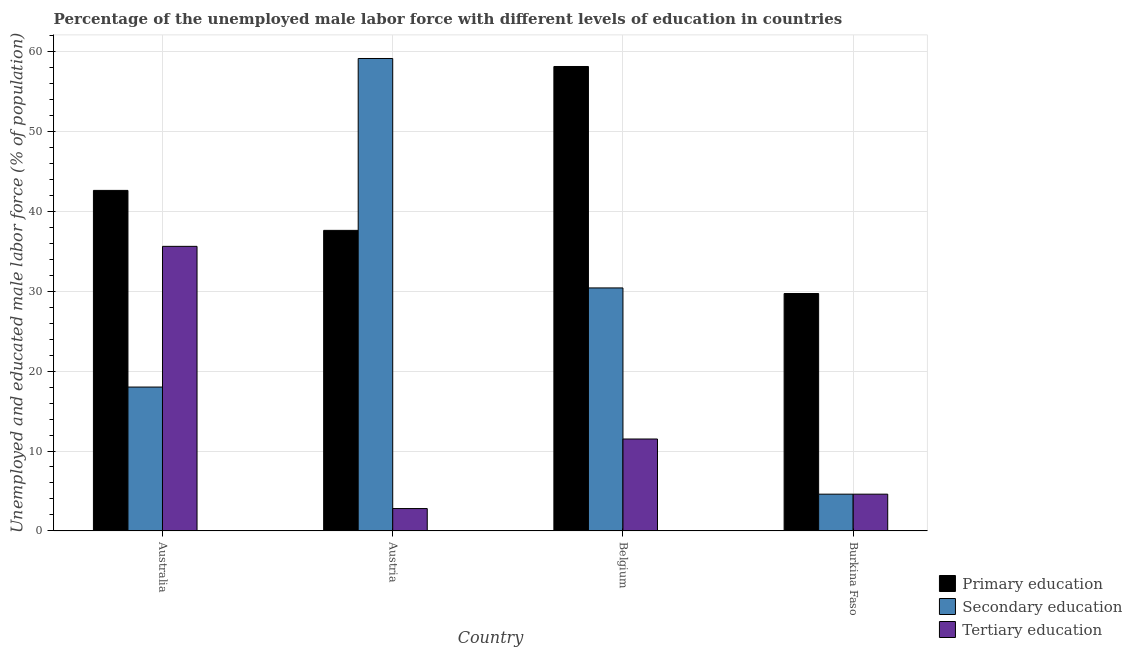In how many cases, is the number of bars for a given country not equal to the number of legend labels?
Keep it short and to the point. 0. What is the percentage of male labor force who received primary education in Belgium?
Make the answer very short. 58.1. Across all countries, what is the maximum percentage of male labor force who received tertiary education?
Keep it short and to the point. 35.6. Across all countries, what is the minimum percentage of male labor force who received tertiary education?
Give a very brief answer. 2.8. In which country was the percentage of male labor force who received secondary education minimum?
Keep it short and to the point. Burkina Faso. What is the total percentage of male labor force who received primary education in the graph?
Your response must be concise. 168. What is the difference between the percentage of male labor force who received tertiary education in Australia and that in Austria?
Make the answer very short. 32.8. What is the difference between the percentage of male labor force who received tertiary education in Australia and the percentage of male labor force who received secondary education in Austria?
Provide a short and direct response. -23.5. What is the average percentage of male labor force who received secondary education per country?
Your answer should be compact. 28.02. What is the difference between the percentage of male labor force who received tertiary education and percentage of male labor force who received primary education in Burkina Faso?
Give a very brief answer. -25.1. In how many countries, is the percentage of male labor force who received secondary education greater than 52 %?
Provide a short and direct response. 1. What is the ratio of the percentage of male labor force who received primary education in Australia to that in Austria?
Provide a short and direct response. 1.13. Is the percentage of male labor force who received tertiary education in Austria less than that in Belgium?
Keep it short and to the point. Yes. Is the difference between the percentage of male labor force who received primary education in Australia and Austria greater than the difference between the percentage of male labor force who received secondary education in Australia and Austria?
Ensure brevity in your answer.  Yes. What is the difference between the highest and the second highest percentage of male labor force who received secondary education?
Provide a succinct answer. 28.7. What is the difference between the highest and the lowest percentage of male labor force who received primary education?
Your answer should be very brief. 28.4. What does the 3rd bar from the left in Burkina Faso represents?
Keep it short and to the point. Tertiary education. What does the 2nd bar from the right in Burkina Faso represents?
Offer a very short reply. Secondary education. Is it the case that in every country, the sum of the percentage of male labor force who received primary education and percentage of male labor force who received secondary education is greater than the percentage of male labor force who received tertiary education?
Your response must be concise. Yes. Are all the bars in the graph horizontal?
Your answer should be very brief. No. How are the legend labels stacked?
Make the answer very short. Vertical. What is the title of the graph?
Make the answer very short. Percentage of the unemployed male labor force with different levels of education in countries. Does "Ages 50+" appear as one of the legend labels in the graph?
Make the answer very short. No. What is the label or title of the X-axis?
Your response must be concise. Country. What is the label or title of the Y-axis?
Make the answer very short. Unemployed and educated male labor force (% of population). What is the Unemployed and educated male labor force (% of population) in Primary education in Australia?
Ensure brevity in your answer.  42.6. What is the Unemployed and educated male labor force (% of population) of Tertiary education in Australia?
Give a very brief answer. 35.6. What is the Unemployed and educated male labor force (% of population) in Primary education in Austria?
Your answer should be compact. 37.6. What is the Unemployed and educated male labor force (% of population) in Secondary education in Austria?
Offer a terse response. 59.1. What is the Unemployed and educated male labor force (% of population) in Tertiary education in Austria?
Ensure brevity in your answer.  2.8. What is the Unemployed and educated male labor force (% of population) in Primary education in Belgium?
Provide a short and direct response. 58.1. What is the Unemployed and educated male labor force (% of population) of Secondary education in Belgium?
Make the answer very short. 30.4. What is the Unemployed and educated male labor force (% of population) in Primary education in Burkina Faso?
Give a very brief answer. 29.7. What is the Unemployed and educated male labor force (% of population) in Secondary education in Burkina Faso?
Your response must be concise. 4.6. What is the Unemployed and educated male labor force (% of population) in Tertiary education in Burkina Faso?
Ensure brevity in your answer.  4.6. Across all countries, what is the maximum Unemployed and educated male labor force (% of population) in Primary education?
Offer a terse response. 58.1. Across all countries, what is the maximum Unemployed and educated male labor force (% of population) in Secondary education?
Your answer should be very brief. 59.1. Across all countries, what is the maximum Unemployed and educated male labor force (% of population) of Tertiary education?
Provide a short and direct response. 35.6. Across all countries, what is the minimum Unemployed and educated male labor force (% of population) of Primary education?
Make the answer very short. 29.7. Across all countries, what is the minimum Unemployed and educated male labor force (% of population) in Secondary education?
Keep it short and to the point. 4.6. Across all countries, what is the minimum Unemployed and educated male labor force (% of population) of Tertiary education?
Keep it short and to the point. 2.8. What is the total Unemployed and educated male labor force (% of population) of Primary education in the graph?
Offer a very short reply. 168. What is the total Unemployed and educated male labor force (% of population) in Secondary education in the graph?
Offer a terse response. 112.1. What is the total Unemployed and educated male labor force (% of population) in Tertiary education in the graph?
Give a very brief answer. 54.5. What is the difference between the Unemployed and educated male labor force (% of population) in Secondary education in Australia and that in Austria?
Your answer should be compact. -41.1. What is the difference between the Unemployed and educated male labor force (% of population) of Tertiary education in Australia and that in Austria?
Your answer should be compact. 32.8. What is the difference between the Unemployed and educated male labor force (% of population) of Primary education in Australia and that in Belgium?
Make the answer very short. -15.5. What is the difference between the Unemployed and educated male labor force (% of population) in Secondary education in Australia and that in Belgium?
Offer a terse response. -12.4. What is the difference between the Unemployed and educated male labor force (% of population) in Tertiary education in Australia and that in Belgium?
Give a very brief answer. 24.1. What is the difference between the Unemployed and educated male labor force (% of population) of Secondary education in Australia and that in Burkina Faso?
Your response must be concise. 13.4. What is the difference between the Unemployed and educated male labor force (% of population) in Tertiary education in Australia and that in Burkina Faso?
Your answer should be very brief. 31. What is the difference between the Unemployed and educated male labor force (% of population) of Primary education in Austria and that in Belgium?
Your answer should be very brief. -20.5. What is the difference between the Unemployed and educated male labor force (% of population) of Secondary education in Austria and that in Belgium?
Your answer should be very brief. 28.7. What is the difference between the Unemployed and educated male labor force (% of population) in Tertiary education in Austria and that in Belgium?
Make the answer very short. -8.7. What is the difference between the Unemployed and educated male labor force (% of population) in Secondary education in Austria and that in Burkina Faso?
Keep it short and to the point. 54.5. What is the difference between the Unemployed and educated male labor force (% of population) of Primary education in Belgium and that in Burkina Faso?
Ensure brevity in your answer.  28.4. What is the difference between the Unemployed and educated male labor force (% of population) of Secondary education in Belgium and that in Burkina Faso?
Ensure brevity in your answer.  25.8. What is the difference between the Unemployed and educated male labor force (% of population) of Tertiary education in Belgium and that in Burkina Faso?
Provide a succinct answer. 6.9. What is the difference between the Unemployed and educated male labor force (% of population) of Primary education in Australia and the Unemployed and educated male labor force (% of population) of Secondary education in Austria?
Ensure brevity in your answer.  -16.5. What is the difference between the Unemployed and educated male labor force (% of population) in Primary education in Australia and the Unemployed and educated male labor force (% of population) in Tertiary education in Austria?
Offer a terse response. 39.8. What is the difference between the Unemployed and educated male labor force (% of population) of Secondary education in Australia and the Unemployed and educated male labor force (% of population) of Tertiary education in Austria?
Offer a terse response. 15.2. What is the difference between the Unemployed and educated male labor force (% of population) in Primary education in Australia and the Unemployed and educated male labor force (% of population) in Tertiary education in Belgium?
Your response must be concise. 31.1. What is the difference between the Unemployed and educated male labor force (% of population) of Secondary education in Australia and the Unemployed and educated male labor force (% of population) of Tertiary education in Belgium?
Offer a terse response. 6.5. What is the difference between the Unemployed and educated male labor force (% of population) in Primary education in Australia and the Unemployed and educated male labor force (% of population) in Secondary education in Burkina Faso?
Your answer should be compact. 38. What is the difference between the Unemployed and educated male labor force (% of population) of Primary education in Austria and the Unemployed and educated male labor force (% of population) of Secondary education in Belgium?
Provide a succinct answer. 7.2. What is the difference between the Unemployed and educated male labor force (% of population) in Primary education in Austria and the Unemployed and educated male labor force (% of population) in Tertiary education in Belgium?
Make the answer very short. 26.1. What is the difference between the Unemployed and educated male labor force (% of population) in Secondary education in Austria and the Unemployed and educated male labor force (% of population) in Tertiary education in Belgium?
Give a very brief answer. 47.6. What is the difference between the Unemployed and educated male labor force (% of population) of Secondary education in Austria and the Unemployed and educated male labor force (% of population) of Tertiary education in Burkina Faso?
Your answer should be very brief. 54.5. What is the difference between the Unemployed and educated male labor force (% of population) in Primary education in Belgium and the Unemployed and educated male labor force (% of population) in Secondary education in Burkina Faso?
Give a very brief answer. 53.5. What is the difference between the Unemployed and educated male labor force (% of population) in Primary education in Belgium and the Unemployed and educated male labor force (% of population) in Tertiary education in Burkina Faso?
Offer a terse response. 53.5. What is the difference between the Unemployed and educated male labor force (% of population) of Secondary education in Belgium and the Unemployed and educated male labor force (% of population) of Tertiary education in Burkina Faso?
Offer a very short reply. 25.8. What is the average Unemployed and educated male labor force (% of population) in Primary education per country?
Offer a very short reply. 42. What is the average Unemployed and educated male labor force (% of population) of Secondary education per country?
Provide a succinct answer. 28.02. What is the average Unemployed and educated male labor force (% of population) in Tertiary education per country?
Your answer should be very brief. 13.62. What is the difference between the Unemployed and educated male labor force (% of population) in Primary education and Unemployed and educated male labor force (% of population) in Secondary education in Australia?
Your answer should be compact. 24.6. What is the difference between the Unemployed and educated male labor force (% of population) in Primary education and Unemployed and educated male labor force (% of population) in Tertiary education in Australia?
Provide a succinct answer. 7. What is the difference between the Unemployed and educated male labor force (% of population) of Secondary education and Unemployed and educated male labor force (% of population) of Tertiary education in Australia?
Ensure brevity in your answer.  -17.6. What is the difference between the Unemployed and educated male labor force (% of population) of Primary education and Unemployed and educated male labor force (% of population) of Secondary education in Austria?
Give a very brief answer. -21.5. What is the difference between the Unemployed and educated male labor force (% of population) of Primary education and Unemployed and educated male labor force (% of population) of Tertiary education in Austria?
Your response must be concise. 34.8. What is the difference between the Unemployed and educated male labor force (% of population) of Secondary education and Unemployed and educated male labor force (% of population) of Tertiary education in Austria?
Offer a very short reply. 56.3. What is the difference between the Unemployed and educated male labor force (% of population) in Primary education and Unemployed and educated male labor force (% of population) in Secondary education in Belgium?
Ensure brevity in your answer.  27.7. What is the difference between the Unemployed and educated male labor force (% of population) in Primary education and Unemployed and educated male labor force (% of population) in Tertiary education in Belgium?
Offer a very short reply. 46.6. What is the difference between the Unemployed and educated male labor force (% of population) of Secondary education and Unemployed and educated male labor force (% of population) of Tertiary education in Belgium?
Make the answer very short. 18.9. What is the difference between the Unemployed and educated male labor force (% of population) of Primary education and Unemployed and educated male labor force (% of population) of Secondary education in Burkina Faso?
Give a very brief answer. 25.1. What is the difference between the Unemployed and educated male labor force (% of population) of Primary education and Unemployed and educated male labor force (% of population) of Tertiary education in Burkina Faso?
Give a very brief answer. 25.1. What is the difference between the Unemployed and educated male labor force (% of population) of Secondary education and Unemployed and educated male labor force (% of population) of Tertiary education in Burkina Faso?
Your answer should be very brief. 0. What is the ratio of the Unemployed and educated male labor force (% of population) of Primary education in Australia to that in Austria?
Your response must be concise. 1.13. What is the ratio of the Unemployed and educated male labor force (% of population) in Secondary education in Australia to that in Austria?
Provide a succinct answer. 0.3. What is the ratio of the Unemployed and educated male labor force (% of population) in Tertiary education in Australia to that in Austria?
Your answer should be very brief. 12.71. What is the ratio of the Unemployed and educated male labor force (% of population) in Primary education in Australia to that in Belgium?
Provide a short and direct response. 0.73. What is the ratio of the Unemployed and educated male labor force (% of population) of Secondary education in Australia to that in Belgium?
Provide a succinct answer. 0.59. What is the ratio of the Unemployed and educated male labor force (% of population) of Tertiary education in Australia to that in Belgium?
Your answer should be very brief. 3.1. What is the ratio of the Unemployed and educated male labor force (% of population) of Primary education in Australia to that in Burkina Faso?
Provide a succinct answer. 1.43. What is the ratio of the Unemployed and educated male labor force (% of population) of Secondary education in Australia to that in Burkina Faso?
Keep it short and to the point. 3.91. What is the ratio of the Unemployed and educated male labor force (% of population) of Tertiary education in Australia to that in Burkina Faso?
Your answer should be compact. 7.74. What is the ratio of the Unemployed and educated male labor force (% of population) of Primary education in Austria to that in Belgium?
Offer a terse response. 0.65. What is the ratio of the Unemployed and educated male labor force (% of population) in Secondary education in Austria to that in Belgium?
Keep it short and to the point. 1.94. What is the ratio of the Unemployed and educated male labor force (% of population) of Tertiary education in Austria to that in Belgium?
Offer a very short reply. 0.24. What is the ratio of the Unemployed and educated male labor force (% of population) of Primary education in Austria to that in Burkina Faso?
Offer a very short reply. 1.27. What is the ratio of the Unemployed and educated male labor force (% of population) of Secondary education in Austria to that in Burkina Faso?
Ensure brevity in your answer.  12.85. What is the ratio of the Unemployed and educated male labor force (% of population) in Tertiary education in Austria to that in Burkina Faso?
Ensure brevity in your answer.  0.61. What is the ratio of the Unemployed and educated male labor force (% of population) in Primary education in Belgium to that in Burkina Faso?
Your answer should be very brief. 1.96. What is the ratio of the Unemployed and educated male labor force (% of population) in Secondary education in Belgium to that in Burkina Faso?
Your response must be concise. 6.61. What is the difference between the highest and the second highest Unemployed and educated male labor force (% of population) in Secondary education?
Your answer should be very brief. 28.7. What is the difference between the highest and the second highest Unemployed and educated male labor force (% of population) in Tertiary education?
Make the answer very short. 24.1. What is the difference between the highest and the lowest Unemployed and educated male labor force (% of population) in Primary education?
Make the answer very short. 28.4. What is the difference between the highest and the lowest Unemployed and educated male labor force (% of population) in Secondary education?
Your answer should be very brief. 54.5. What is the difference between the highest and the lowest Unemployed and educated male labor force (% of population) of Tertiary education?
Provide a succinct answer. 32.8. 